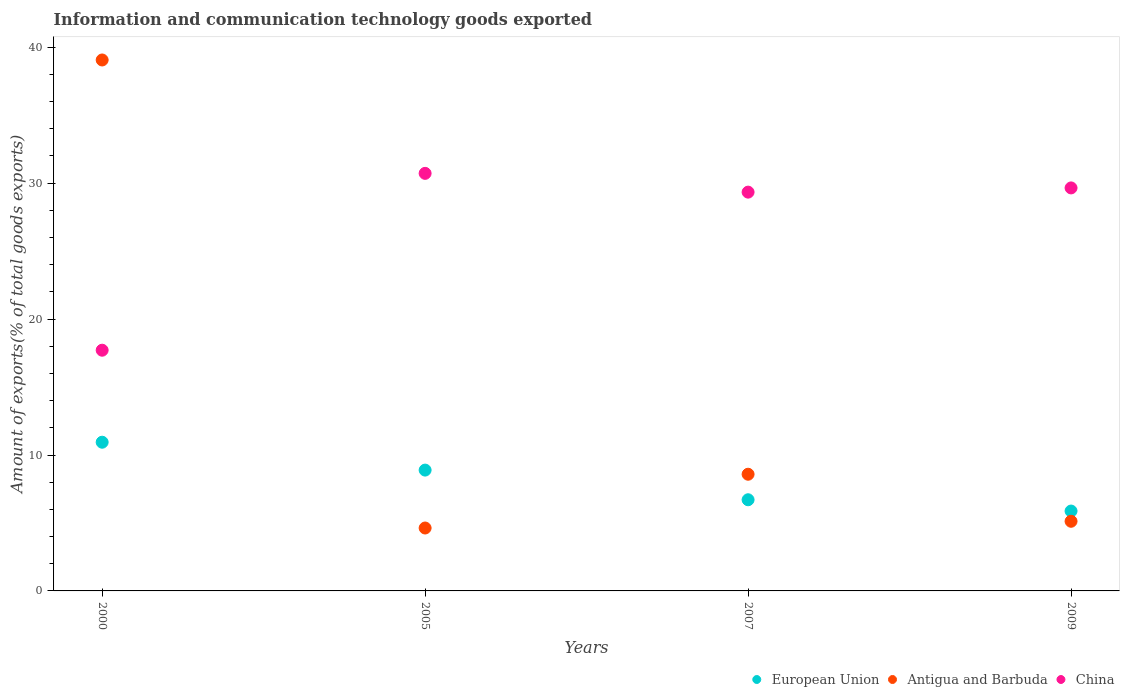What is the amount of goods exported in European Union in 2000?
Provide a short and direct response. 10.94. Across all years, what is the maximum amount of goods exported in China?
Keep it short and to the point. 30.72. Across all years, what is the minimum amount of goods exported in Antigua and Barbuda?
Offer a terse response. 4.63. What is the total amount of goods exported in China in the graph?
Make the answer very short. 107.42. What is the difference between the amount of goods exported in Antigua and Barbuda in 2005 and that in 2007?
Keep it short and to the point. -3.96. What is the difference between the amount of goods exported in Antigua and Barbuda in 2007 and the amount of goods exported in European Union in 2009?
Give a very brief answer. 2.71. What is the average amount of goods exported in Antigua and Barbuda per year?
Provide a succinct answer. 14.35. In the year 2009, what is the difference between the amount of goods exported in Antigua and Barbuda and amount of goods exported in European Union?
Provide a short and direct response. -0.75. In how many years, is the amount of goods exported in Antigua and Barbuda greater than 30 %?
Offer a terse response. 1. What is the ratio of the amount of goods exported in China in 2000 to that in 2005?
Ensure brevity in your answer.  0.58. Is the amount of goods exported in China in 2000 less than that in 2009?
Provide a succinct answer. Yes. What is the difference between the highest and the second highest amount of goods exported in European Union?
Offer a very short reply. 2.05. What is the difference between the highest and the lowest amount of goods exported in Antigua and Barbuda?
Provide a short and direct response. 34.44. Is the sum of the amount of goods exported in Antigua and Barbuda in 2000 and 2005 greater than the maximum amount of goods exported in China across all years?
Ensure brevity in your answer.  Yes. Is it the case that in every year, the sum of the amount of goods exported in China and amount of goods exported in European Union  is greater than the amount of goods exported in Antigua and Barbuda?
Provide a short and direct response. No. Does the amount of goods exported in European Union monotonically increase over the years?
Offer a terse response. No. How many dotlines are there?
Your answer should be very brief. 3. How many years are there in the graph?
Your answer should be very brief. 4. What is the difference between two consecutive major ticks on the Y-axis?
Ensure brevity in your answer.  10. Does the graph contain grids?
Keep it short and to the point. No. Where does the legend appear in the graph?
Keep it short and to the point. Bottom right. How many legend labels are there?
Make the answer very short. 3. How are the legend labels stacked?
Make the answer very short. Horizontal. What is the title of the graph?
Offer a very short reply. Information and communication technology goods exported. Does "Cayman Islands" appear as one of the legend labels in the graph?
Your answer should be very brief. No. What is the label or title of the Y-axis?
Your answer should be compact. Amount of exports(% of total goods exports). What is the Amount of exports(% of total goods exports) in European Union in 2000?
Offer a terse response. 10.94. What is the Amount of exports(% of total goods exports) in Antigua and Barbuda in 2000?
Offer a terse response. 39.06. What is the Amount of exports(% of total goods exports) in China in 2000?
Keep it short and to the point. 17.71. What is the Amount of exports(% of total goods exports) in European Union in 2005?
Your answer should be compact. 8.89. What is the Amount of exports(% of total goods exports) in Antigua and Barbuda in 2005?
Your answer should be very brief. 4.63. What is the Amount of exports(% of total goods exports) in China in 2005?
Provide a succinct answer. 30.72. What is the Amount of exports(% of total goods exports) in European Union in 2007?
Keep it short and to the point. 6.71. What is the Amount of exports(% of total goods exports) of Antigua and Barbuda in 2007?
Ensure brevity in your answer.  8.58. What is the Amount of exports(% of total goods exports) in China in 2007?
Provide a succinct answer. 29.34. What is the Amount of exports(% of total goods exports) of European Union in 2009?
Make the answer very short. 5.88. What is the Amount of exports(% of total goods exports) in Antigua and Barbuda in 2009?
Offer a very short reply. 5.12. What is the Amount of exports(% of total goods exports) in China in 2009?
Make the answer very short. 29.65. Across all years, what is the maximum Amount of exports(% of total goods exports) in European Union?
Your answer should be compact. 10.94. Across all years, what is the maximum Amount of exports(% of total goods exports) in Antigua and Barbuda?
Provide a succinct answer. 39.06. Across all years, what is the maximum Amount of exports(% of total goods exports) in China?
Make the answer very short. 30.72. Across all years, what is the minimum Amount of exports(% of total goods exports) of European Union?
Your answer should be compact. 5.88. Across all years, what is the minimum Amount of exports(% of total goods exports) in Antigua and Barbuda?
Offer a terse response. 4.63. Across all years, what is the minimum Amount of exports(% of total goods exports) of China?
Give a very brief answer. 17.71. What is the total Amount of exports(% of total goods exports) in European Union in the graph?
Your answer should be very brief. 32.41. What is the total Amount of exports(% of total goods exports) of Antigua and Barbuda in the graph?
Offer a terse response. 57.4. What is the total Amount of exports(% of total goods exports) in China in the graph?
Ensure brevity in your answer.  107.42. What is the difference between the Amount of exports(% of total goods exports) in European Union in 2000 and that in 2005?
Give a very brief answer. 2.05. What is the difference between the Amount of exports(% of total goods exports) in Antigua and Barbuda in 2000 and that in 2005?
Your answer should be very brief. 34.44. What is the difference between the Amount of exports(% of total goods exports) of China in 2000 and that in 2005?
Provide a short and direct response. -13.01. What is the difference between the Amount of exports(% of total goods exports) of European Union in 2000 and that in 2007?
Your response must be concise. 4.23. What is the difference between the Amount of exports(% of total goods exports) in Antigua and Barbuda in 2000 and that in 2007?
Offer a very short reply. 30.48. What is the difference between the Amount of exports(% of total goods exports) in China in 2000 and that in 2007?
Provide a succinct answer. -11.63. What is the difference between the Amount of exports(% of total goods exports) of European Union in 2000 and that in 2009?
Provide a short and direct response. 5.06. What is the difference between the Amount of exports(% of total goods exports) in Antigua and Barbuda in 2000 and that in 2009?
Provide a short and direct response. 33.94. What is the difference between the Amount of exports(% of total goods exports) in China in 2000 and that in 2009?
Offer a terse response. -11.94. What is the difference between the Amount of exports(% of total goods exports) of European Union in 2005 and that in 2007?
Provide a short and direct response. 2.18. What is the difference between the Amount of exports(% of total goods exports) in Antigua and Barbuda in 2005 and that in 2007?
Keep it short and to the point. -3.96. What is the difference between the Amount of exports(% of total goods exports) of China in 2005 and that in 2007?
Your response must be concise. 1.38. What is the difference between the Amount of exports(% of total goods exports) of European Union in 2005 and that in 2009?
Ensure brevity in your answer.  3.01. What is the difference between the Amount of exports(% of total goods exports) in Antigua and Barbuda in 2005 and that in 2009?
Your answer should be compact. -0.5. What is the difference between the Amount of exports(% of total goods exports) in China in 2005 and that in 2009?
Make the answer very short. 1.07. What is the difference between the Amount of exports(% of total goods exports) in European Union in 2007 and that in 2009?
Provide a succinct answer. 0.83. What is the difference between the Amount of exports(% of total goods exports) of Antigua and Barbuda in 2007 and that in 2009?
Give a very brief answer. 3.46. What is the difference between the Amount of exports(% of total goods exports) in China in 2007 and that in 2009?
Give a very brief answer. -0.31. What is the difference between the Amount of exports(% of total goods exports) in European Union in 2000 and the Amount of exports(% of total goods exports) in Antigua and Barbuda in 2005?
Keep it short and to the point. 6.31. What is the difference between the Amount of exports(% of total goods exports) of European Union in 2000 and the Amount of exports(% of total goods exports) of China in 2005?
Your response must be concise. -19.78. What is the difference between the Amount of exports(% of total goods exports) of Antigua and Barbuda in 2000 and the Amount of exports(% of total goods exports) of China in 2005?
Your answer should be very brief. 8.34. What is the difference between the Amount of exports(% of total goods exports) of European Union in 2000 and the Amount of exports(% of total goods exports) of Antigua and Barbuda in 2007?
Keep it short and to the point. 2.36. What is the difference between the Amount of exports(% of total goods exports) in European Union in 2000 and the Amount of exports(% of total goods exports) in China in 2007?
Keep it short and to the point. -18.4. What is the difference between the Amount of exports(% of total goods exports) of Antigua and Barbuda in 2000 and the Amount of exports(% of total goods exports) of China in 2007?
Provide a short and direct response. 9.72. What is the difference between the Amount of exports(% of total goods exports) of European Union in 2000 and the Amount of exports(% of total goods exports) of Antigua and Barbuda in 2009?
Provide a short and direct response. 5.82. What is the difference between the Amount of exports(% of total goods exports) of European Union in 2000 and the Amount of exports(% of total goods exports) of China in 2009?
Offer a terse response. -18.71. What is the difference between the Amount of exports(% of total goods exports) of Antigua and Barbuda in 2000 and the Amount of exports(% of total goods exports) of China in 2009?
Keep it short and to the point. 9.41. What is the difference between the Amount of exports(% of total goods exports) in European Union in 2005 and the Amount of exports(% of total goods exports) in Antigua and Barbuda in 2007?
Your answer should be very brief. 0.3. What is the difference between the Amount of exports(% of total goods exports) in European Union in 2005 and the Amount of exports(% of total goods exports) in China in 2007?
Your answer should be very brief. -20.45. What is the difference between the Amount of exports(% of total goods exports) in Antigua and Barbuda in 2005 and the Amount of exports(% of total goods exports) in China in 2007?
Your answer should be compact. -24.71. What is the difference between the Amount of exports(% of total goods exports) in European Union in 2005 and the Amount of exports(% of total goods exports) in Antigua and Barbuda in 2009?
Ensure brevity in your answer.  3.77. What is the difference between the Amount of exports(% of total goods exports) of European Union in 2005 and the Amount of exports(% of total goods exports) of China in 2009?
Ensure brevity in your answer.  -20.76. What is the difference between the Amount of exports(% of total goods exports) in Antigua and Barbuda in 2005 and the Amount of exports(% of total goods exports) in China in 2009?
Give a very brief answer. -25.02. What is the difference between the Amount of exports(% of total goods exports) of European Union in 2007 and the Amount of exports(% of total goods exports) of Antigua and Barbuda in 2009?
Your response must be concise. 1.58. What is the difference between the Amount of exports(% of total goods exports) in European Union in 2007 and the Amount of exports(% of total goods exports) in China in 2009?
Give a very brief answer. -22.94. What is the difference between the Amount of exports(% of total goods exports) of Antigua and Barbuda in 2007 and the Amount of exports(% of total goods exports) of China in 2009?
Offer a very short reply. -21.07. What is the average Amount of exports(% of total goods exports) in European Union per year?
Your answer should be compact. 8.1. What is the average Amount of exports(% of total goods exports) in Antigua and Barbuda per year?
Provide a succinct answer. 14.35. What is the average Amount of exports(% of total goods exports) in China per year?
Make the answer very short. 26.86. In the year 2000, what is the difference between the Amount of exports(% of total goods exports) of European Union and Amount of exports(% of total goods exports) of Antigua and Barbuda?
Your answer should be compact. -28.12. In the year 2000, what is the difference between the Amount of exports(% of total goods exports) of European Union and Amount of exports(% of total goods exports) of China?
Give a very brief answer. -6.77. In the year 2000, what is the difference between the Amount of exports(% of total goods exports) in Antigua and Barbuda and Amount of exports(% of total goods exports) in China?
Ensure brevity in your answer.  21.35. In the year 2005, what is the difference between the Amount of exports(% of total goods exports) of European Union and Amount of exports(% of total goods exports) of Antigua and Barbuda?
Give a very brief answer. 4.26. In the year 2005, what is the difference between the Amount of exports(% of total goods exports) of European Union and Amount of exports(% of total goods exports) of China?
Ensure brevity in your answer.  -21.83. In the year 2005, what is the difference between the Amount of exports(% of total goods exports) of Antigua and Barbuda and Amount of exports(% of total goods exports) of China?
Provide a succinct answer. -26.09. In the year 2007, what is the difference between the Amount of exports(% of total goods exports) in European Union and Amount of exports(% of total goods exports) in Antigua and Barbuda?
Provide a succinct answer. -1.88. In the year 2007, what is the difference between the Amount of exports(% of total goods exports) in European Union and Amount of exports(% of total goods exports) in China?
Provide a succinct answer. -22.63. In the year 2007, what is the difference between the Amount of exports(% of total goods exports) of Antigua and Barbuda and Amount of exports(% of total goods exports) of China?
Offer a very short reply. -20.76. In the year 2009, what is the difference between the Amount of exports(% of total goods exports) in European Union and Amount of exports(% of total goods exports) in Antigua and Barbuda?
Offer a very short reply. 0.75. In the year 2009, what is the difference between the Amount of exports(% of total goods exports) in European Union and Amount of exports(% of total goods exports) in China?
Your answer should be compact. -23.77. In the year 2009, what is the difference between the Amount of exports(% of total goods exports) of Antigua and Barbuda and Amount of exports(% of total goods exports) of China?
Give a very brief answer. -24.53. What is the ratio of the Amount of exports(% of total goods exports) of European Union in 2000 to that in 2005?
Offer a terse response. 1.23. What is the ratio of the Amount of exports(% of total goods exports) of Antigua and Barbuda in 2000 to that in 2005?
Your response must be concise. 8.44. What is the ratio of the Amount of exports(% of total goods exports) of China in 2000 to that in 2005?
Make the answer very short. 0.58. What is the ratio of the Amount of exports(% of total goods exports) of European Union in 2000 to that in 2007?
Your response must be concise. 1.63. What is the ratio of the Amount of exports(% of total goods exports) in Antigua and Barbuda in 2000 to that in 2007?
Your answer should be very brief. 4.55. What is the ratio of the Amount of exports(% of total goods exports) in China in 2000 to that in 2007?
Keep it short and to the point. 0.6. What is the ratio of the Amount of exports(% of total goods exports) of European Union in 2000 to that in 2009?
Provide a succinct answer. 1.86. What is the ratio of the Amount of exports(% of total goods exports) of Antigua and Barbuda in 2000 to that in 2009?
Offer a terse response. 7.62. What is the ratio of the Amount of exports(% of total goods exports) in China in 2000 to that in 2009?
Keep it short and to the point. 0.6. What is the ratio of the Amount of exports(% of total goods exports) in European Union in 2005 to that in 2007?
Make the answer very short. 1.33. What is the ratio of the Amount of exports(% of total goods exports) of Antigua and Barbuda in 2005 to that in 2007?
Your answer should be very brief. 0.54. What is the ratio of the Amount of exports(% of total goods exports) in China in 2005 to that in 2007?
Provide a succinct answer. 1.05. What is the ratio of the Amount of exports(% of total goods exports) of European Union in 2005 to that in 2009?
Provide a succinct answer. 1.51. What is the ratio of the Amount of exports(% of total goods exports) of Antigua and Barbuda in 2005 to that in 2009?
Make the answer very short. 0.9. What is the ratio of the Amount of exports(% of total goods exports) of China in 2005 to that in 2009?
Offer a very short reply. 1.04. What is the ratio of the Amount of exports(% of total goods exports) in European Union in 2007 to that in 2009?
Give a very brief answer. 1.14. What is the ratio of the Amount of exports(% of total goods exports) in Antigua and Barbuda in 2007 to that in 2009?
Ensure brevity in your answer.  1.68. What is the difference between the highest and the second highest Amount of exports(% of total goods exports) in European Union?
Offer a very short reply. 2.05. What is the difference between the highest and the second highest Amount of exports(% of total goods exports) of Antigua and Barbuda?
Offer a terse response. 30.48. What is the difference between the highest and the second highest Amount of exports(% of total goods exports) in China?
Offer a very short reply. 1.07. What is the difference between the highest and the lowest Amount of exports(% of total goods exports) in European Union?
Provide a succinct answer. 5.06. What is the difference between the highest and the lowest Amount of exports(% of total goods exports) of Antigua and Barbuda?
Keep it short and to the point. 34.44. What is the difference between the highest and the lowest Amount of exports(% of total goods exports) in China?
Your answer should be compact. 13.01. 